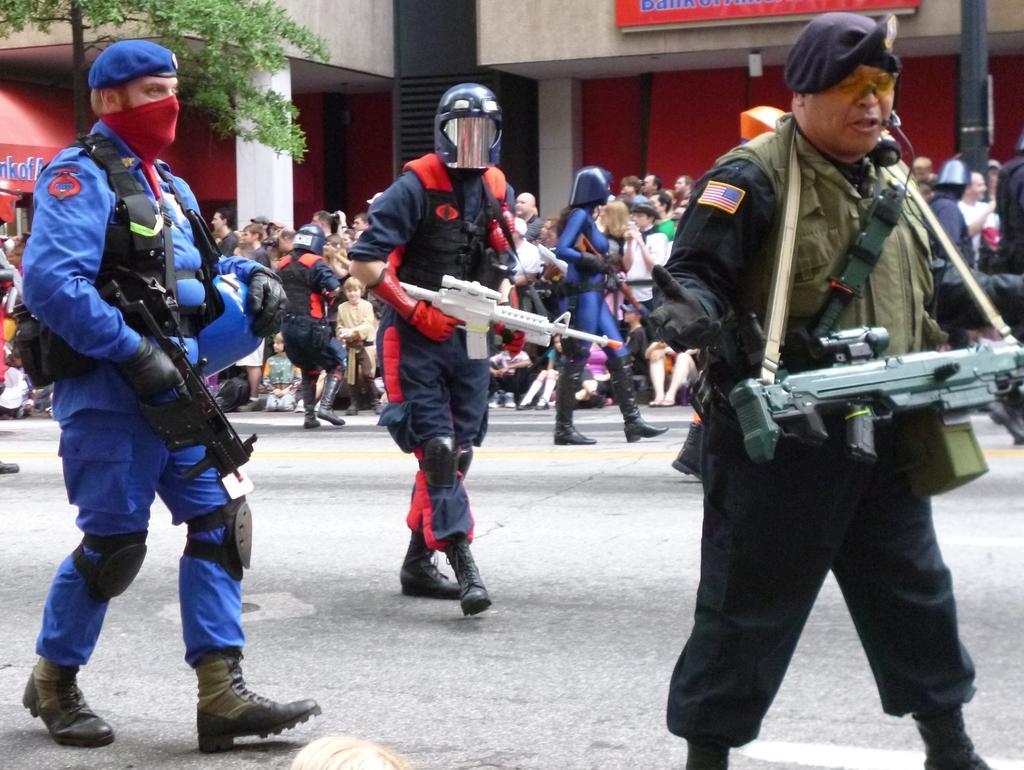Could you give a brief overview of what you see in this image? In this image we can see people holding rifles. They are wearing helmets. At the bottom there is a road. In the background there are buildings. On the left we can see a tree. 